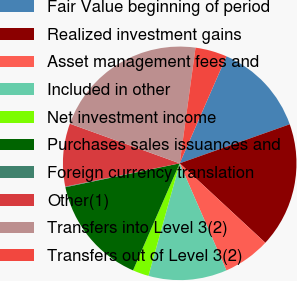Convert chart. <chart><loc_0><loc_0><loc_500><loc_500><pie_chart><fcel>Fair Value beginning of period<fcel>Realized investment gains<fcel>Asset management fees and<fcel>Included in other<fcel>Net investment income<fcel>Purchases sales issuances and<fcel>Foreign currency translation<fcel>Other(1)<fcel>Transfers into Level 3(2)<fcel>Transfers out of Level 3(2)<nl><fcel>13.02%<fcel>17.33%<fcel>6.55%<fcel>10.86%<fcel>2.23%<fcel>15.18%<fcel>0.08%<fcel>8.71%<fcel>21.65%<fcel>4.39%<nl></chart> 